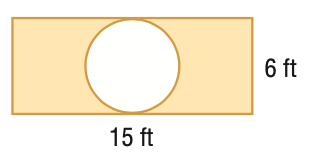Answer the mathemtical geometry problem and directly provide the correct option letter.
Question: Find the area of the shaded region. Round to the nearest tenth.
Choices: A: 61.7 B: 71.2 C: 90 D: 118.3 A 